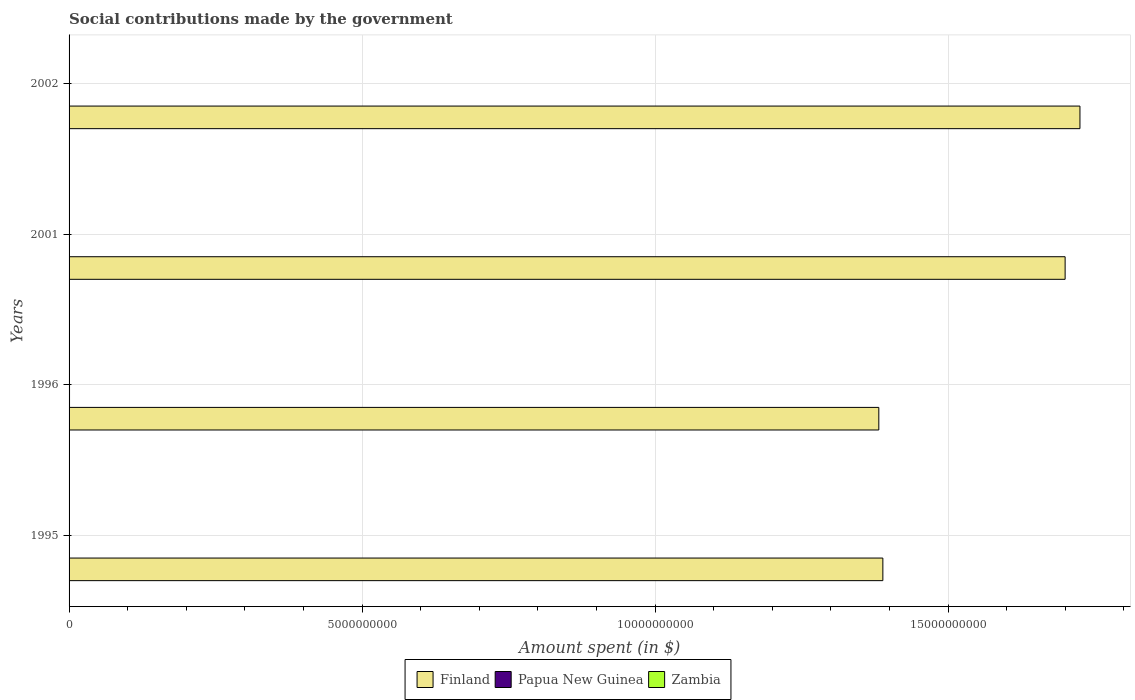How many different coloured bars are there?
Keep it short and to the point. 3. How many groups of bars are there?
Give a very brief answer. 4. How many bars are there on the 1st tick from the top?
Keep it short and to the point. 3. How many bars are there on the 2nd tick from the bottom?
Your answer should be compact. 3. In how many cases, is the number of bars for a given year not equal to the number of legend labels?
Make the answer very short. 0. What is the amount spent on social contributions in Zambia in 2002?
Provide a succinct answer. 5150. Across all years, what is the maximum amount spent on social contributions in Zambia?
Provide a succinct answer. 1.20e+04. Across all years, what is the minimum amount spent on social contributions in Papua New Guinea?
Your response must be concise. 4.00e+06. In which year was the amount spent on social contributions in Papua New Guinea maximum?
Keep it short and to the point. 1996. What is the total amount spent on social contributions in Finland in the graph?
Make the answer very short. 6.19e+1. What is the difference between the amount spent on social contributions in Zambia in 1995 and that in 2002?
Ensure brevity in your answer.  -4250. What is the difference between the amount spent on social contributions in Finland in 1995 and the amount spent on social contributions in Papua New Guinea in 2002?
Ensure brevity in your answer.  1.39e+1. What is the average amount spent on social contributions in Papua New Guinea per year?
Provide a short and direct response. 5.90e+06. In the year 1996, what is the difference between the amount spent on social contributions in Zambia and amount spent on social contributions in Finland?
Keep it short and to the point. -1.38e+1. What is the ratio of the amount spent on social contributions in Papua New Guinea in 1996 to that in 2001?
Your answer should be very brief. 1.97. Is the difference between the amount spent on social contributions in Zambia in 1995 and 1996 greater than the difference between the amount spent on social contributions in Finland in 1995 and 1996?
Provide a succinct answer. No. What is the difference between the highest and the second highest amount spent on social contributions in Finland?
Ensure brevity in your answer.  2.53e+08. What is the difference between the highest and the lowest amount spent on social contributions in Finland?
Provide a succinct answer. 3.43e+09. Is the sum of the amount spent on social contributions in Zambia in 1995 and 2002 greater than the maximum amount spent on social contributions in Papua New Guinea across all years?
Ensure brevity in your answer.  No. What does the 2nd bar from the top in 2002 represents?
Offer a terse response. Papua New Guinea. What does the 3rd bar from the bottom in 1996 represents?
Provide a short and direct response. Zambia. How many bars are there?
Provide a short and direct response. 12. How many years are there in the graph?
Offer a terse response. 4. Are the values on the major ticks of X-axis written in scientific E-notation?
Ensure brevity in your answer.  No. Where does the legend appear in the graph?
Offer a terse response. Bottom center. How are the legend labels stacked?
Make the answer very short. Horizontal. What is the title of the graph?
Make the answer very short. Social contributions made by the government. Does "Bulgaria" appear as one of the legend labels in the graph?
Your response must be concise. No. What is the label or title of the X-axis?
Keep it short and to the point. Amount spent (in $). What is the Amount spent (in $) of Finland in 1995?
Give a very brief answer. 1.39e+1. What is the Amount spent (in $) of Papua New Guinea in 1995?
Your answer should be compact. 7.29e+06. What is the Amount spent (in $) in Zambia in 1995?
Provide a short and direct response. 900. What is the Amount spent (in $) in Finland in 1996?
Your answer should be very brief. 1.38e+1. What is the Amount spent (in $) of Papua New Guinea in 1996?
Offer a terse response. 7.87e+06. What is the Amount spent (in $) of Zambia in 1996?
Your answer should be compact. 600. What is the Amount spent (in $) of Finland in 2001?
Provide a succinct answer. 1.70e+1. What is the Amount spent (in $) in Papua New Guinea in 2001?
Offer a very short reply. 4.00e+06. What is the Amount spent (in $) of Zambia in 2001?
Make the answer very short. 1.20e+04. What is the Amount spent (in $) of Finland in 2002?
Provide a succinct answer. 1.72e+1. What is the Amount spent (in $) of Papua New Guinea in 2002?
Provide a succinct answer. 4.45e+06. What is the Amount spent (in $) of Zambia in 2002?
Offer a very short reply. 5150. Across all years, what is the maximum Amount spent (in $) of Finland?
Your response must be concise. 1.72e+1. Across all years, what is the maximum Amount spent (in $) in Papua New Guinea?
Offer a very short reply. 7.87e+06. Across all years, what is the maximum Amount spent (in $) in Zambia?
Your answer should be very brief. 1.20e+04. Across all years, what is the minimum Amount spent (in $) in Finland?
Your answer should be compact. 1.38e+1. Across all years, what is the minimum Amount spent (in $) of Papua New Guinea?
Your answer should be very brief. 4.00e+06. Across all years, what is the minimum Amount spent (in $) in Zambia?
Offer a very short reply. 600. What is the total Amount spent (in $) in Finland in the graph?
Ensure brevity in your answer.  6.19e+1. What is the total Amount spent (in $) of Papua New Guinea in the graph?
Your answer should be very brief. 2.36e+07. What is the total Amount spent (in $) of Zambia in the graph?
Offer a terse response. 1.86e+04. What is the difference between the Amount spent (in $) of Finland in 1995 and that in 1996?
Offer a very short reply. 6.90e+07. What is the difference between the Amount spent (in $) in Papua New Guinea in 1995 and that in 1996?
Provide a succinct answer. -5.87e+05. What is the difference between the Amount spent (in $) of Zambia in 1995 and that in 1996?
Your answer should be compact. 300. What is the difference between the Amount spent (in $) in Finland in 1995 and that in 2001?
Keep it short and to the point. -3.11e+09. What is the difference between the Amount spent (in $) of Papua New Guinea in 1995 and that in 2001?
Provide a short and direct response. 3.28e+06. What is the difference between the Amount spent (in $) in Zambia in 1995 and that in 2001?
Your answer should be compact. -1.11e+04. What is the difference between the Amount spent (in $) of Finland in 1995 and that in 2002?
Offer a terse response. -3.36e+09. What is the difference between the Amount spent (in $) in Papua New Guinea in 1995 and that in 2002?
Ensure brevity in your answer.  2.84e+06. What is the difference between the Amount spent (in $) of Zambia in 1995 and that in 2002?
Ensure brevity in your answer.  -4250. What is the difference between the Amount spent (in $) of Finland in 1996 and that in 2001?
Your answer should be very brief. -3.18e+09. What is the difference between the Amount spent (in $) of Papua New Guinea in 1996 and that in 2001?
Give a very brief answer. 3.87e+06. What is the difference between the Amount spent (in $) in Zambia in 1996 and that in 2001?
Provide a succinct answer. -1.14e+04. What is the difference between the Amount spent (in $) in Finland in 1996 and that in 2002?
Ensure brevity in your answer.  -3.43e+09. What is the difference between the Amount spent (in $) of Papua New Guinea in 1996 and that in 2002?
Ensure brevity in your answer.  3.43e+06. What is the difference between the Amount spent (in $) in Zambia in 1996 and that in 2002?
Offer a terse response. -4550. What is the difference between the Amount spent (in $) of Finland in 2001 and that in 2002?
Your answer should be very brief. -2.53e+08. What is the difference between the Amount spent (in $) of Papua New Guinea in 2001 and that in 2002?
Provide a short and direct response. -4.43e+05. What is the difference between the Amount spent (in $) in Zambia in 2001 and that in 2002?
Give a very brief answer. 6810.51. What is the difference between the Amount spent (in $) of Finland in 1995 and the Amount spent (in $) of Papua New Guinea in 1996?
Make the answer very short. 1.39e+1. What is the difference between the Amount spent (in $) of Finland in 1995 and the Amount spent (in $) of Zambia in 1996?
Offer a terse response. 1.39e+1. What is the difference between the Amount spent (in $) in Papua New Guinea in 1995 and the Amount spent (in $) in Zambia in 1996?
Your answer should be compact. 7.29e+06. What is the difference between the Amount spent (in $) of Finland in 1995 and the Amount spent (in $) of Papua New Guinea in 2001?
Your answer should be very brief. 1.39e+1. What is the difference between the Amount spent (in $) of Finland in 1995 and the Amount spent (in $) of Zambia in 2001?
Offer a terse response. 1.39e+1. What is the difference between the Amount spent (in $) of Papua New Guinea in 1995 and the Amount spent (in $) of Zambia in 2001?
Offer a terse response. 7.28e+06. What is the difference between the Amount spent (in $) in Finland in 1995 and the Amount spent (in $) in Papua New Guinea in 2002?
Make the answer very short. 1.39e+1. What is the difference between the Amount spent (in $) in Finland in 1995 and the Amount spent (in $) in Zambia in 2002?
Offer a terse response. 1.39e+1. What is the difference between the Amount spent (in $) in Papua New Guinea in 1995 and the Amount spent (in $) in Zambia in 2002?
Make the answer very short. 7.28e+06. What is the difference between the Amount spent (in $) of Finland in 1996 and the Amount spent (in $) of Papua New Guinea in 2001?
Keep it short and to the point. 1.38e+1. What is the difference between the Amount spent (in $) of Finland in 1996 and the Amount spent (in $) of Zambia in 2001?
Ensure brevity in your answer.  1.38e+1. What is the difference between the Amount spent (in $) in Papua New Guinea in 1996 and the Amount spent (in $) in Zambia in 2001?
Make the answer very short. 7.86e+06. What is the difference between the Amount spent (in $) in Finland in 1996 and the Amount spent (in $) in Papua New Guinea in 2002?
Offer a terse response. 1.38e+1. What is the difference between the Amount spent (in $) in Finland in 1996 and the Amount spent (in $) in Zambia in 2002?
Offer a terse response. 1.38e+1. What is the difference between the Amount spent (in $) of Papua New Guinea in 1996 and the Amount spent (in $) of Zambia in 2002?
Your response must be concise. 7.87e+06. What is the difference between the Amount spent (in $) in Finland in 2001 and the Amount spent (in $) in Papua New Guinea in 2002?
Ensure brevity in your answer.  1.70e+1. What is the difference between the Amount spent (in $) in Finland in 2001 and the Amount spent (in $) in Zambia in 2002?
Ensure brevity in your answer.  1.70e+1. What is the difference between the Amount spent (in $) of Papua New Guinea in 2001 and the Amount spent (in $) of Zambia in 2002?
Provide a succinct answer. 4.00e+06. What is the average Amount spent (in $) in Finland per year?
Your answer should be very brief. 1.55e+1. What is the average Amount spent (in $) of Papua New Guinea per year?
Offer a terse response. 5.90e+06. What is the average Amount spent (in $) of Zambia per year?
Your response must be concise. 4652.63. In the year 1995, what is the difference between the Amount spent (in $) of Finland and Amount spent (in $) of Papua New Guinea?
Provide a short and direct response. 1.39e+1. In the year 1995, what is the difference between the Amount spent (in $) of Finland and Amount spent (in $) of Zambia?
Make the answer very short. 1.39e+1. In the year 1995, what is the difference between the Amount spent (in $) of Papua New Guinea and Amount spent (in $) of Zambia?
Give a very brief answer. 7.29e+06. In the year 1996, what is the difference between the Amount spent (in $) in Finland and Amount spent (in $) in Papua New Guinea?
Give a very brief answer. 1.38e+1. In the year 1996, what is the difference between the Amount spent (in $) of Finland and Amount spent (in $) of Zambia?
Make the answer very short. 1.38e+1. In the year 1996, what is the difference between the Amount spent (in $) in Papua New Guinea and Amount spent (in $) in Zambia?
Make the answer very short. 7.87e+06. In the year 2001, what is the difference between the Amount spent (in $) in Finland and Amount spent (in $) in Papua New Guinea?
Make the answer very short. 1.70e+1. In the year 2001, what is the difference between the Amount spent (in $) of Finland and Amount spent (in $) of Zambia?
Give a very brief answer. 1.70e+1. In the year 2001, what is the difference between the Amount spent (in $) in Papua New Guinea and Amount spent (in $) in Zambia?
Your answer should be compact. 3.99e+06. In the year 2002, what is the difference between the Amount spent (in $) in Finland and Amount spent (in $) in Papua New Guinea?
Give a very brief answer. 1.72e+1. In the year 2002, what is the difference between the Amount spent (in $) of Finland and Amount spent (in $) of Zambia?
Keep it short and to the point. 1.72e+1. In the year 2002, what is the difference between the Amount spent (in $) of Papua New Guinea and Amount spent (in $) of Zambia?
Provide a short and direct response. 4.44e+06. What is the ratio of the Amount spent (in $) of Finland in 1995 to that in 1996?
Your answer should be very brief. 1. What is the ratio of the Amount spent (in $) in Papua New Guinea in 1995 to that in 1996?
Your response must be concise. 0.93. What is the ratio of the Amount spent (in $) of Zambia in 1995 to that in 1996?
Offer a very short reply. 1.5. What is the ratio of the Amount spent (in $) in Finland in 1995 to that in 2001?
Keep it short and to the point. 0.82. What is the ratio of the Amount spent (in $) of Papua New Guinea in 1995 to that in 2001?
Keep it short and to the point. 1.82. What is the ratio of the Amount spent (in $) of Zambia in 1995 to that in 2001?
Make the answer very short. 0.08. What is the ratio of the Amount spent (in $) of Finland in 1995 to that in 2002?
Give a very brief answer. 0.81. What is the ratio of the Amount spent (in $) of Papua New Guinea in 1995 to that in 2002?
Offer a very short reply. 1.64. What is the ratio of the Amount spent (in $) in Zambia in 1995 to that in 2002?
Offer a very short reply. 0.17. What is the ratio of the Amount spent (in $) of Finland in 1996 to that in 2001?
Your answer should be very brief. 0.81. What is the ratio of the Amount spent (in $) of Papua New Guinea in 1996 to that in 2001?
Your answer should be very brief. 1.97. What is the ratio of the Amount spent (in $) of Zambia in 1996 to that in 2001?
Offer a very short reply. 0.05. What is the ratio of the Amount spent (in $) of Finland in 1996 to that in 2002?
Your response must be concise. 0.8. What is the ratio of the Amount spent (in $) of Papua New Guinea in 1996 to that in 2002?
Your answer should be compact. 1.77. What is the ratio of the Amount spent (in $) of Zambia in 1996 to that in 2002?
Give a very brief answer. 0.12. What is the ratio of the Amount spent (in $) of Finland in 2001 to that in 2002?
Give a very brief answer. 0.99. What is the ratio of the Amount spent (in $) in Papua New Guinea in 2001 to that in 2002?
Your answer should be compact. 0.9. What is the ratio of the Amount spent (in $) in Zambia in 2001 to that in 2002?
Your answer should be very brief. 2.32. What is the difference between the highest and the second highest Amount spent (in $) of Finland?
Offer a terse response. 2.53e+08. What is the difference between the highest and the second highest Amount spent (in $) in Papua New Guinea?
Provide a short and direct response. 5.87e+05. What is the difference between the highest and the second highest Amount spent (in $) in Zambia?
Offer a very short reply. 6810.51. What is the difference between the highest and the lowest Amount spent (in $) of Finland?
Offer a terse response. 3.43e+09. What is the difference between the highest and the lowest Amount spent (in $) of Papua New Guinea?
Make the answer very short. 3.87e+06. What is the difference between the highest and the lowest Amount spent (in $) in Zambia?
Provide a short and direct response. 1.14e+04. 